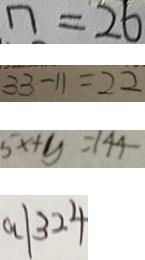Convert formula to latex. <formula><loc_0><loc_0><loc_500><loc_500>n = 2 6 
 3 3 - 1 1 = 2 2 
 5 x + y = 1 4 4 
 a \vert 3 2 4</formula> 